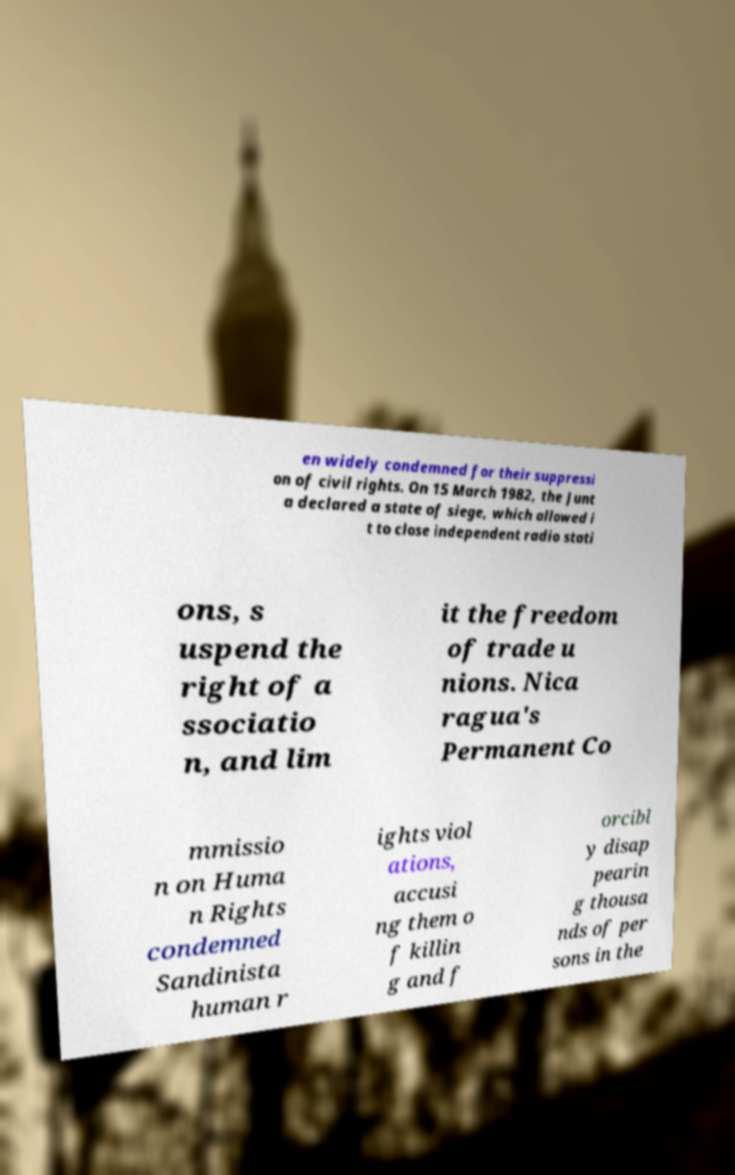Can you read and provide the text displayed in the image?This photo seems to have some interesting text. Can you extract and type it out for me? en widely condemned for their suppressi on of civil rights. On 15 March 1982, the Junt a declared a state of siege, which allowed i t to close independent radio stati ons, s uspend the right of a ssociatio n, and lim it the freedom of trade u nions. Nica ragua's Permanent Co mmissio n on Huma n Rights condemned Sandinista human r ights viol ations, accusi ng them o f killin g and f orcibl y disap pearin g thousa nds of per sons in the 